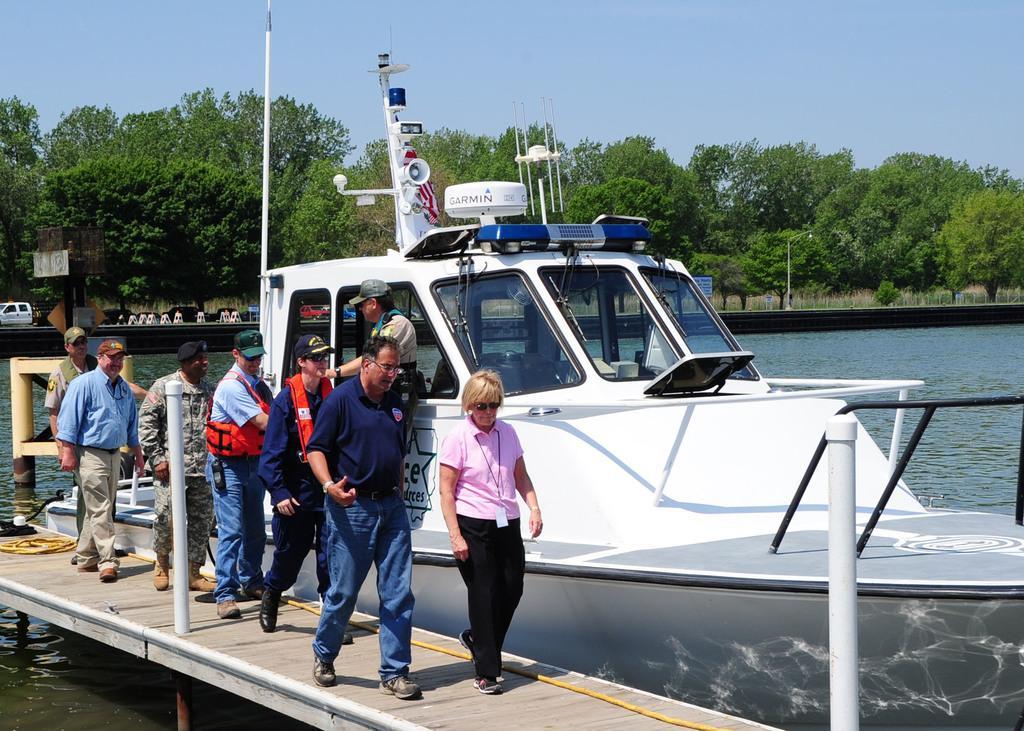Please provide a concise description of this image. In this image there is the sky towards the top of the image, there are trees, there are poles, there is a light, there are vehicles, there is water, there is a boat, there are group of persons walking on the wooden floor, there is a rope. 